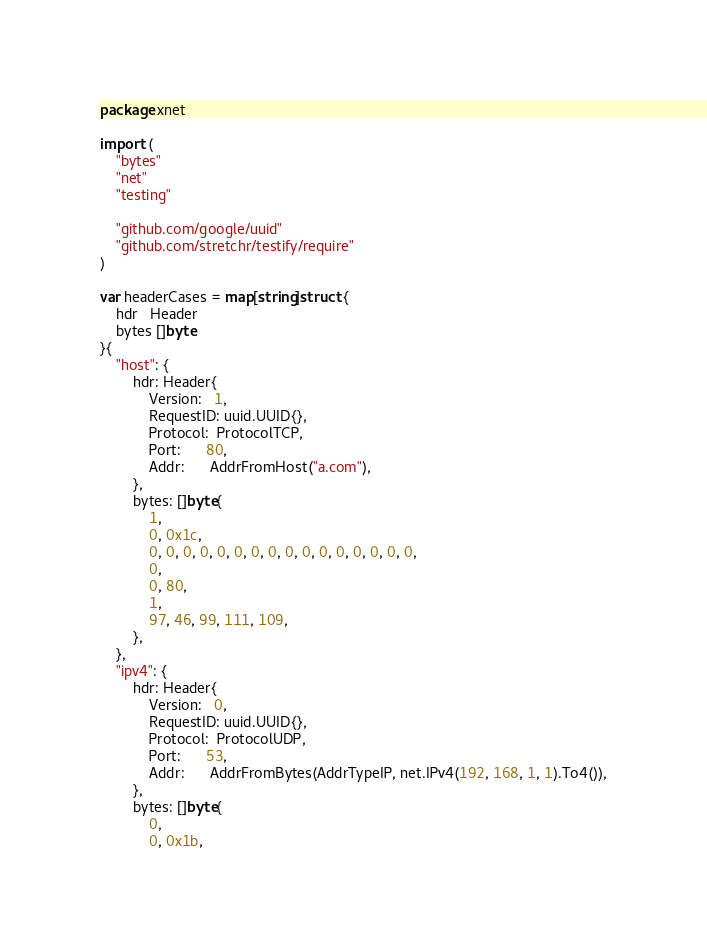<code> <loc_0><loc_0><loc_500><loc_500><_Go_>package xnet

import (
	"bytes"
	"net"
	"testing"

	"github.com/google/uuid"
	"github.com/stretchr/testify/require"
)

var headerCases = map[string]struct {
	hdr   Header
	bytes []byte
}{
	"host": {
		hdr: Header{
			Version:   1,
			RequestID: uuid.UUID{},
			Protocol:  ProtocolTCP,
			Port:      80,
			Addr:      AddrFromHost("a.com"),
		},
		bytes: []byte{
			1,
			0, 0x1c,
			0, 0, 0, 0, 0, 0, 0, 0, 0, 0, 0, 0, 0, 0, 0, 0,
			0,
			0, 80,
			1,
			97, 46, 99, 111, 109,
		},
	},
	"ipv4": {
		hdr: Header{
			Version:   0,
			RequestID: uuid.UUID{},
			Protocol:  ProtocolUDP,
			Port:      53,
			Addr:      AddrFromBytes(AddrTypeIP, net.IPv4(192, 168, 1, 1).To4()),
		},
		bytes: []byte{
			0,
			0, 0x1b,</code> 